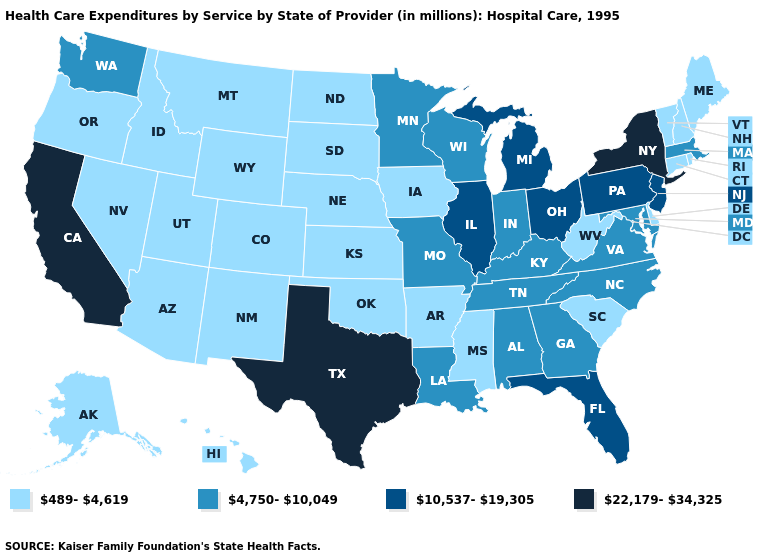Which states have the lowest value in the USA?
Concise answer only. Alaska, Arizona, Arkansas, Colorado, Connecticut, Delaware, Hawaii, Idaho, Iowa, Kansas, Maine, Mississippi, Montana, Nebraska, Nevada, New Hampshire, New Mexico, North Dakota, Oklahoma, Oregon, Rhode Island, South Carolina, South Dakota, Utah, Vermont, West Virginia, Wyoming. What is the highest value in states that border Idaho?
Write a very short answer. 4,750-10,049. Which states hav the highest value in the MidWest?
Short answer required. Illinois, Michigan, Ohio. Name the states that have a value in the range 10,537-19,305?
Write a very short answer. Florida, Illinois, Michigan, New Jersey, Ohio, Pennsylvania. Which states have the lowest value in the Northeast?
Quick response, please. Connecticut, Maine, New Hampshire, Rhode Island, Vermont. What is the highest value in the South ?
Answer briefly. 22,179-34,325. Name the states that have a value in the range 10,537-19,305?
Be succinct. Florida, Illinois, Michigan, New Jersey, Ohio, Pennsylvania. What is the value of Mississippi?
Keep it brief. 489-4,619. Does Maryland have the lowest value in the USA?
Keep it brief. No. Does New Mexico have the highest value in the USA?
Concise answer only. No. Among the states that border Indiana , which have the highest value?
Be succinct. Illinois, Michigan, Ohio. What is the lowest value in the West?
Quick response, please. 489-4,619. Does Indiana have the lowest value in the USA?
Write a very short answer. No. What is the highest value in the Northeast ?
Concise answer only. 22,179-34,325. Is the legend a continuous bar?
Answer briefly. No. 